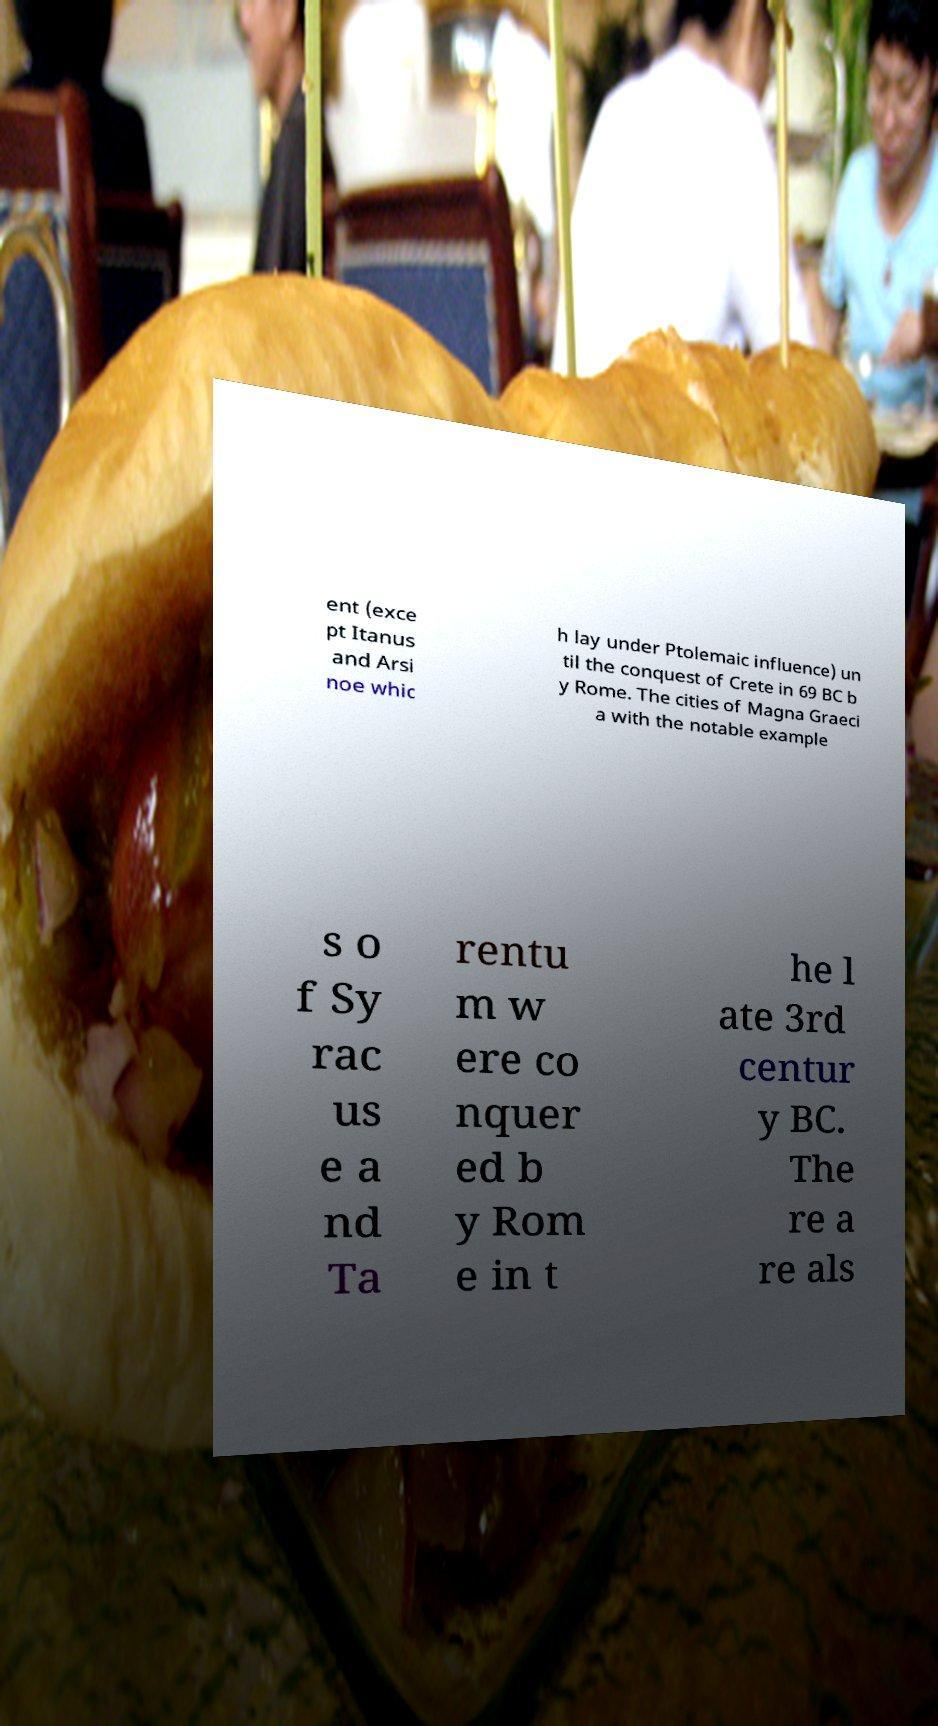I need the written content from this picture converted into text. Can you do that? ent (exce pt Itanus and Arsi noe whic h lay under Ptolemaic influence) un til the conquest of Crete in 69 BC b y Rome. The cities of Magna Graeci a with the notable example s o f Sy rac us e a nd Ta rentu m w ere co nquer ed b y Rom e in t he l ate 3rd centur y BC. The re a re als 